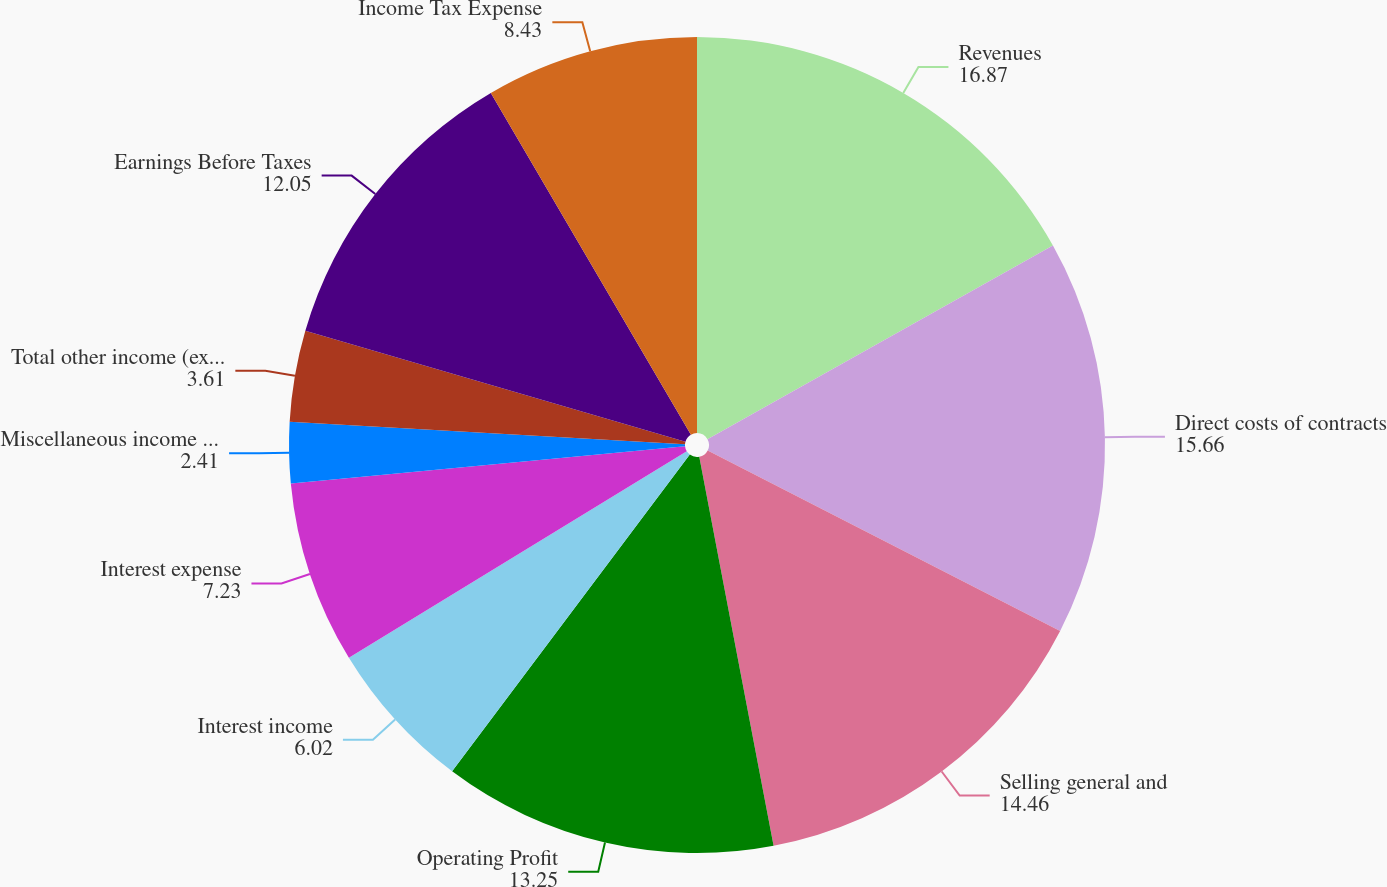<chart> <loc_0><loc_0><loc_500><loc_500><pie_chart><fcel>Revenues<fcel>Direct costs of contracts<fcel>Selling general and<fcel>Operating Profit<fcel>Interest income<fcel>Interest expense<fcel>Miscellaneous income (expense)<fcel>Total other income (expense)<fcel>Earnings Before Taxes<fcel>Income Tax Expense<nl><fcel>16.87%<fcel>15.66%<fcel>14.46%<fcel>13.25%<fcel>6.02%<fcel>7.23%<fcel>2.41%<fcel>3.61%<fcel>12.05%<fcel>8.43%<nl></chart> 